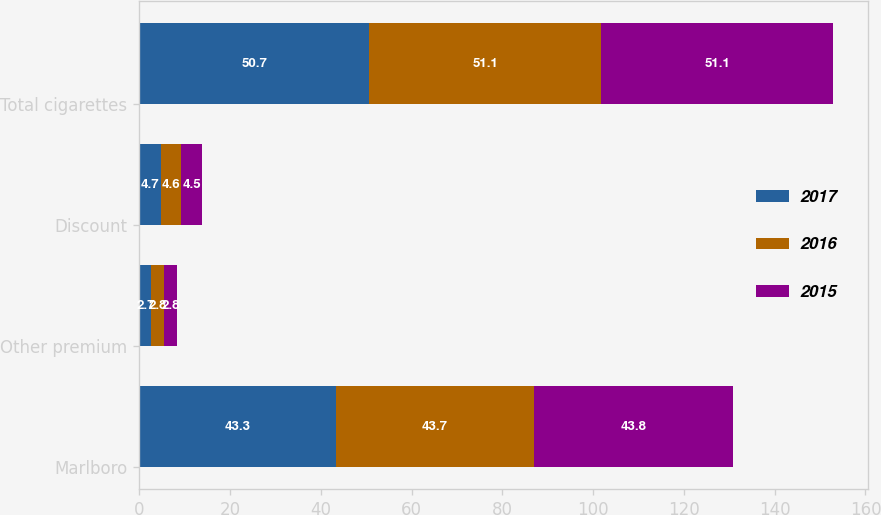Convert chart. <chart><loc_0><loc_0><loc_500><loc_500><stacked_bar_chart><ecel><fcel>Marlboro<fcel>Other premium<fcel>Discount<fcel>Total cigarettes<nl><fcel>2017<fcel>43.3<fcel>2.7<fcel>4.7<fcel>50.7<nl><fcel>2016<fcel>43.7<fcel>2.8<fcel>4.6<fcel>51.1<nl><fcel>2015<fcel>43.8<fcel>2.8<fcel>4.5<fcel>51.1<nl></chart> 